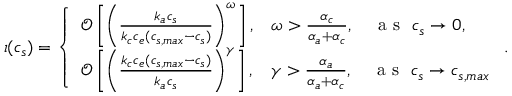<formula> <loc_0><loc_0><loc_500><loc_500>\iota ( c _ { s } ) = \left \{ \begin{array} { l l } { \mathcal { O } \left [ \left ( \frac { k _ { a } c _ { s } } { k _ { c } c _ { e } ( c _ { s , \max } - c _ { s } ) } \right ) ^ { \omega } \right ] , } & { \omega > \frac { \alpha _ { c } } { \alpha _ { a } + \alpha _ { c } } , \quad a s \ c _ { s } \to 0 , } \\ { \mathcal { O } \left [ \left ( \frac { k _ { c } c _ { e } ( c _ { s , \max } - c _ { s } ) } { k _ { a } c _ { s } } \right ) ^ { \gamma } \right ] , } & { \gamma > \frac { \alpha _ { a } } { \alpha _ { a } + \alpha _ { c } } , \quad a s \ c _ { s } \to c _ { s , \max } } \end{array} .</formula> 